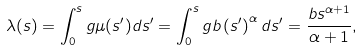Convert formula to latex. <formula><loc_0><loc_0><loc_500><loc_500>\lambda ( s ) = \int _ { 0 } ^ { s } g \mu ( s ^ { \prime } ) d s ^ { \prime } = \int _ { 0 } ^ { s } g b \left ( s ^ { \prime } \right ) ^ { \alpha } d s ^ { \prime } = \frac { b s ^ { \alpha + 1 } } { \alpha + 1 } ,</formula> 